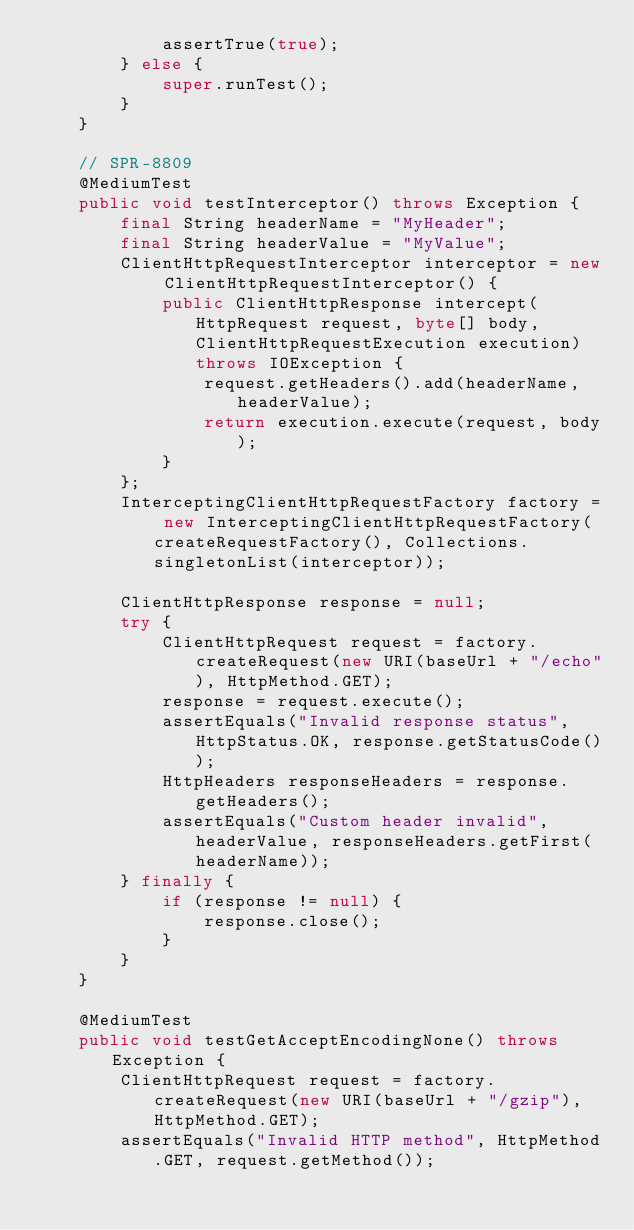Convert code to text. <code><loc_0><loc_0><loc_500><loc_500><_Java_>			assertTrue(true);
		} else {
			super.runTest();
		}
	}

	// SPR-8809
	@MediumTest
	public void testInterceptor() throws Exception {
		final String headerName = "MyHeader";
		final String headerValue = "MyValue";
		ClientHttpRequestInterceptor interceptor = new ClientHttpRequestInterceptor() {
			public ClientHttpResponse intercept(HttpRequest request, byte[] body, ClientHttpRequestExecution execution) throws IOException {
				request.getHeaders().add(headerName, headerValue);
				return execution.execute(request, body);
			}
		};
		InterceptingClientHttpRequestFactory factory = new InterceptingClientHttpRequestFactory(createRequestFactory(), Collections.singletonList(interceptor));

		ClientHttpResponse response = null;
		try {
			ClientHttpRequest request = factory.createRequest(new URI(baseUrl + "/echo"), HttpMethod.GET);
			response = request.execute();
			assertEquals("Invalid response status", HttpStatus.OK, response.getStatusCode());
			HttpHeaders responseHeaders = response.getHeaders();
			assertEquals("Custom header invalid", headerValue, responseHeaders.getFirst(headerName));
		} finally {
			if (response != null) {
				response.close();
			}
		}
	}

	@MediumTest
	public void testGetAcceptEncodingNone() throws Exception {
		ClientHttpRequest request = factory.createRequest(new URI(baseUrl + "/gzip"), HttpMethod.GET);
		assertEquals("Invalid HTTP method", HttpMethod.GET, request.getMethod());</code> 